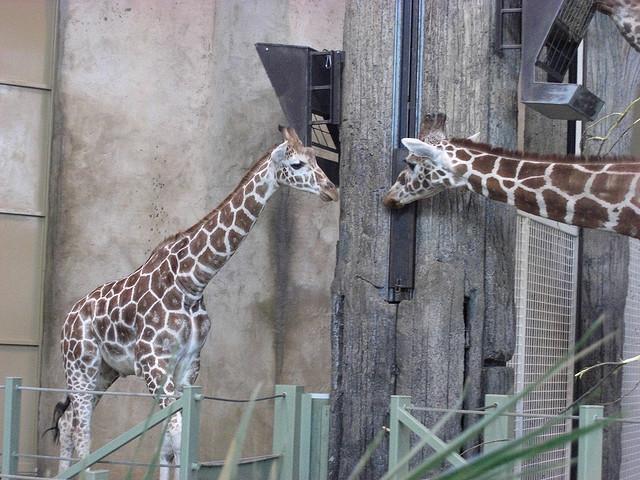How many animals are there?
Give a very brief answer. 2. How many giraffes can you see?
Give a very brief answer. 2. How many people are wearing a hat?
Give a very brief answer. 0. 